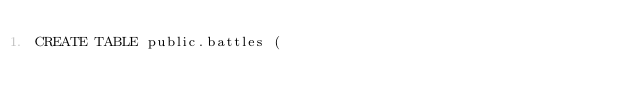Convert code to text. <code><loc_0><loc_0><loc_500><loc_500><_SQL_>CREATE TABLE public.battles (</code> 